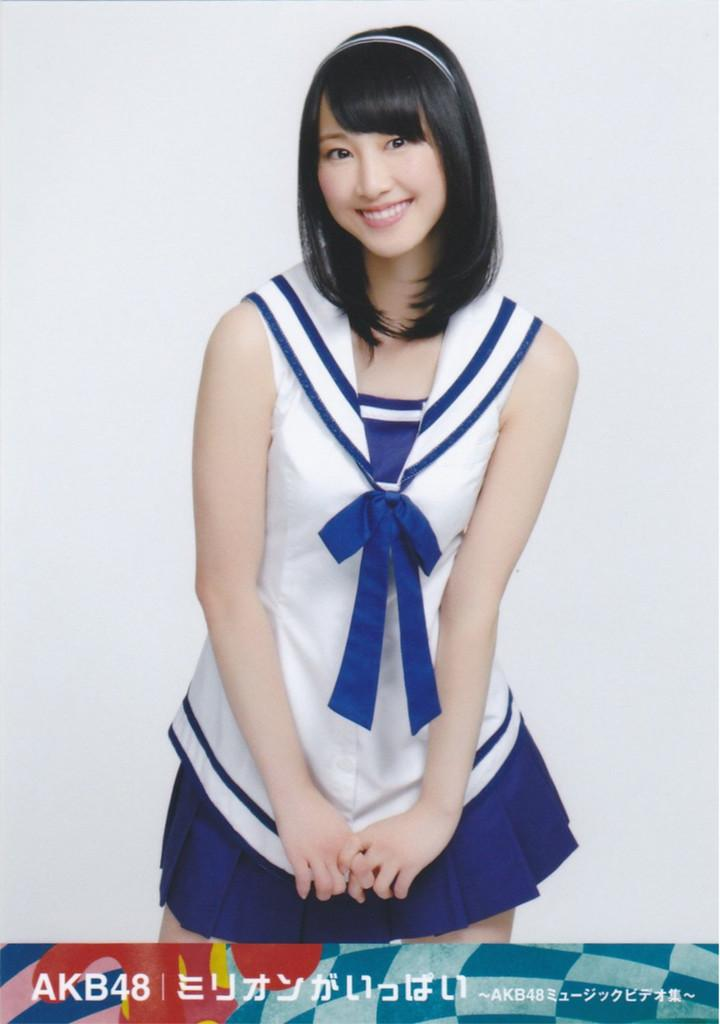<image>
Give a short and clear explanation of the subsequent image. a young female picture with AKB48 and Japanese language at the bottom 